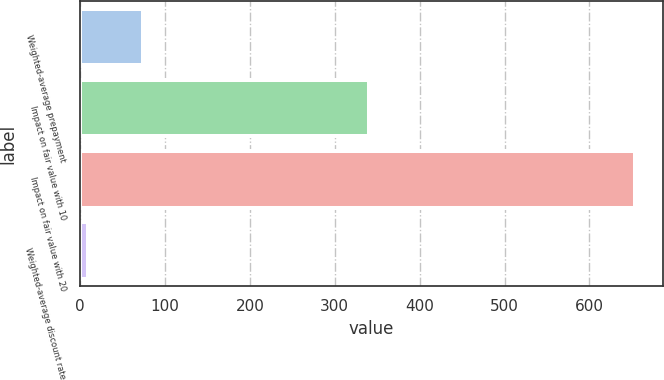Convert chart. <chart><loc_0><loc_0><loc_500><loc_500><bar_chart><fcel>Weighted-average prepayment<fcel>Impact on fair value with 10<fcel>Impact on fair value with 20<fcel>Weighted-average discount rate<nl><fcel>74.11<fcel>340<fcel>654<fcel>9.68<nl></chart> 